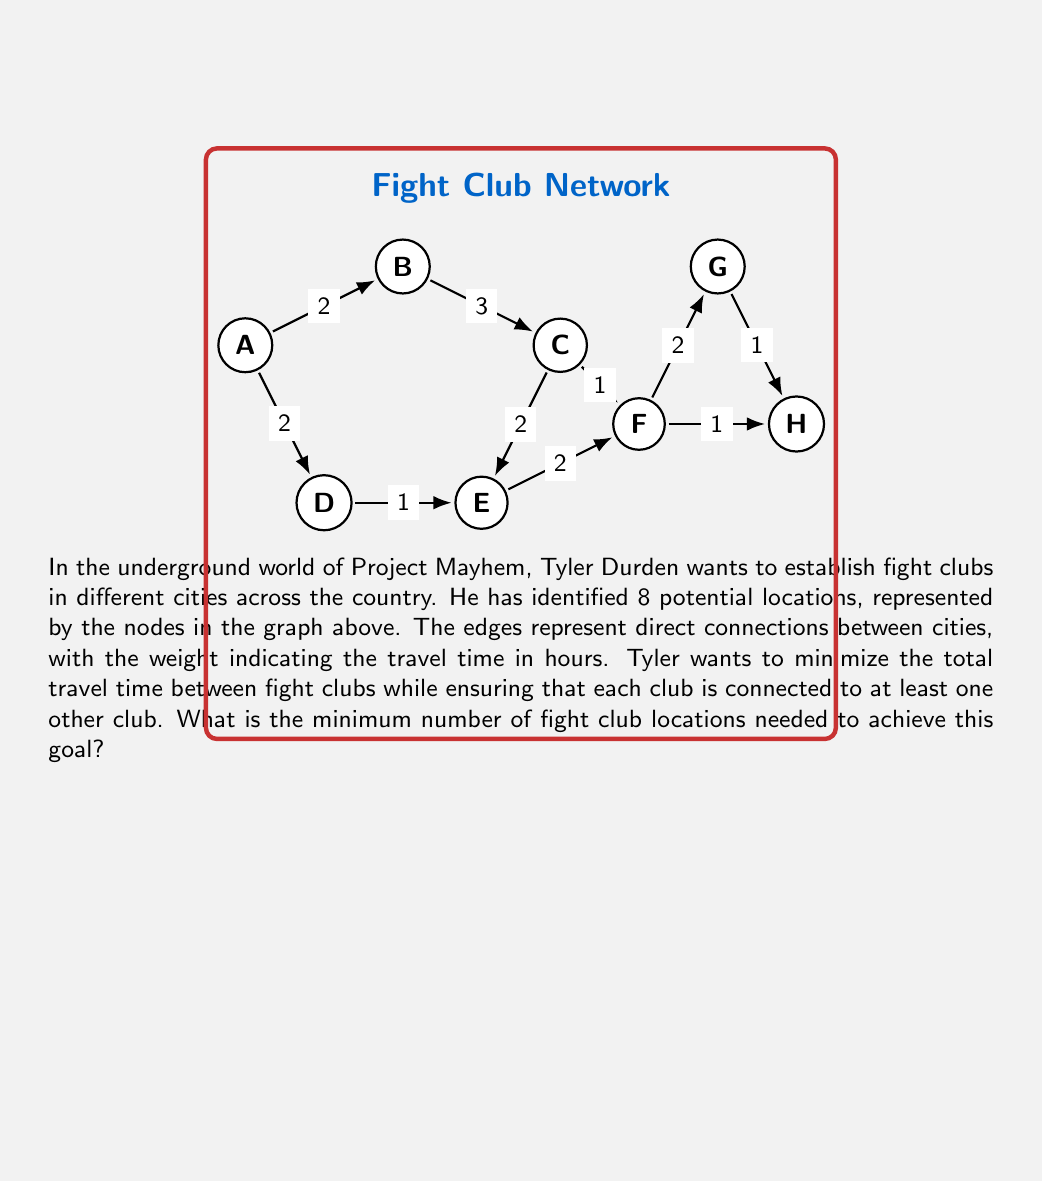Can you answer this question? To solve this problem, we need to find the minimum spanning tree (MST) of the given graph. The MST will give us the minimum number of edges required to connect all nodes while minimizing the total weight (travel time).

Step 1: Identify the algorithm
We'll use Kruskal's algorithm to find the MST.

Step 2: Sort the edges by weight
1. D-E, F-H, G-H (1 hour)
2. A-B, A-D, C-F, E-F, F-G (2 hours)
3. B-C, C-E (3 hours)

Step 3: Apply Kruskal's algorithm
1. Add D-E (1 hour)
2. Add F-H (1 hour)
3. Add G-H (1 hour)
4. Add A-B (2 hours)
5. Add C-F (2 hours)
6. Add A-D (2 hours)
7. Add E-F (2 hours)

The MST is now complete with 7 edges.

Step 4: Calculate the number of fight club locations
In a tree with $n$ nodes, the number of edges is always $n-1$. Since we have 7 edges in our MST, the number of nodes (fight club locations) is:

$$ n = 7 + 1 = 8 $$

Therefore, all 8 locations are needed to ensure connectivity while minimizing travel time.

Step 5: Verify the first rule of Fight Club
Remember, the first rule of Fight Club is: You do not talk about Fight Club. By using all 8 locations, we minimize the need for excessive travel and reduce the risk of exposure.
Answer: 8 locations 